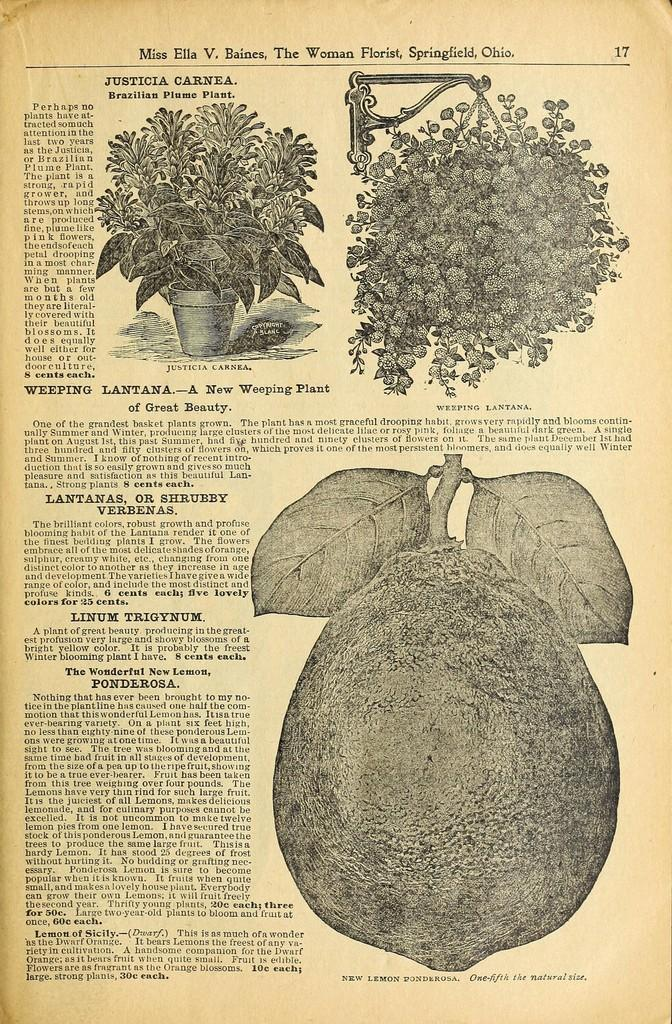What object is located at the top of the image? There is a plant pot at the top of the image. What can be found at the bottom of the image? There is a fruit at the bottom of the image. What type of object has text on it in the image? There is text on a paper in the image. Can you tell me how far away the girl is from the fruit in the image? There is no girl present in the image, so it is not possible to determine the distance between her and the fruit. 